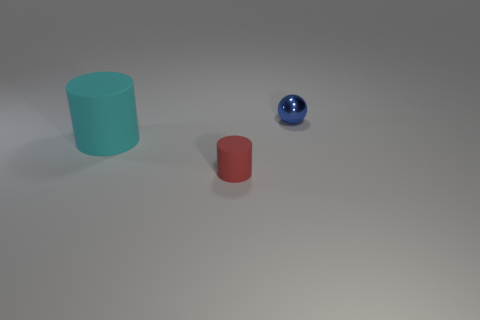What number of objects are large matte objects or cylinders that are to the left of the red cylinder?
Provide a succinct answer. 1. Is the tiny red thing made of the same material as the big object?
Provide a short and direct response. Yes. What number of other objects are the same shape as the tiny red matte thing?
Your answer should be compact. 1. There is a object that is on the right side of the big rubber cylinder and in front of the small ball; how big is it?
Ensure brevity in your answer.  Small. What number of metal things are cyan cylinders or cylinders?
Offer a very short reply. 0. There is a tiny object that is on the left side of the tiny sphere; does it have the same shape as the object that is to the left of the small red rubber thing?
Ensure brevity in your answer.  Yes. Is there a cylinder made of the same material as the large cyan thing?
Your response must be concise. Yes. What color is the tiny shiny thing?
Provide a succinct answer. Blue. What size is the rubber cylinder that is in front of the cyan cylinder?
Your response must be concise. Small. Is there a small blue metallic sphere behind the tiny thing that is in front of the small metallic thing?
Your answer should be compact. Yes. 